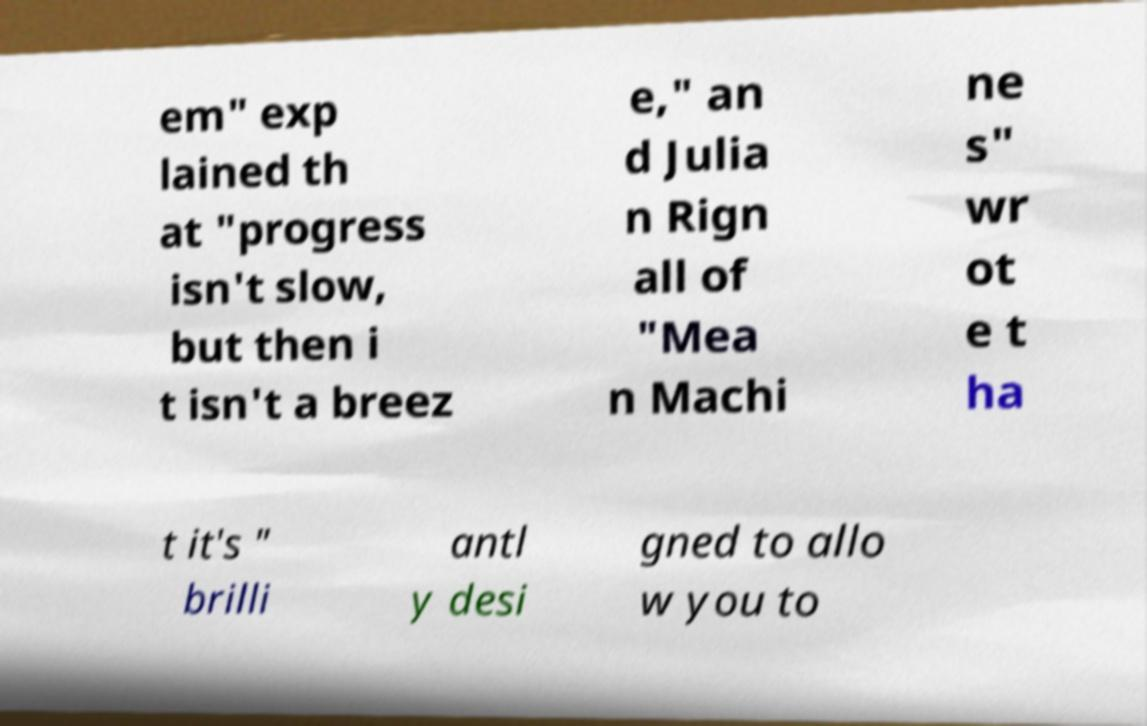Could you assist in decoding the text presented in this image and type it out clearly? em" exp lained th at "progress isn't slow, but then i t isn't a breez e," an d Julia n Rign all of "Mea n Machi ne s" wr ot e t ha t it's " brilli antl y desi gned to allo w you to 